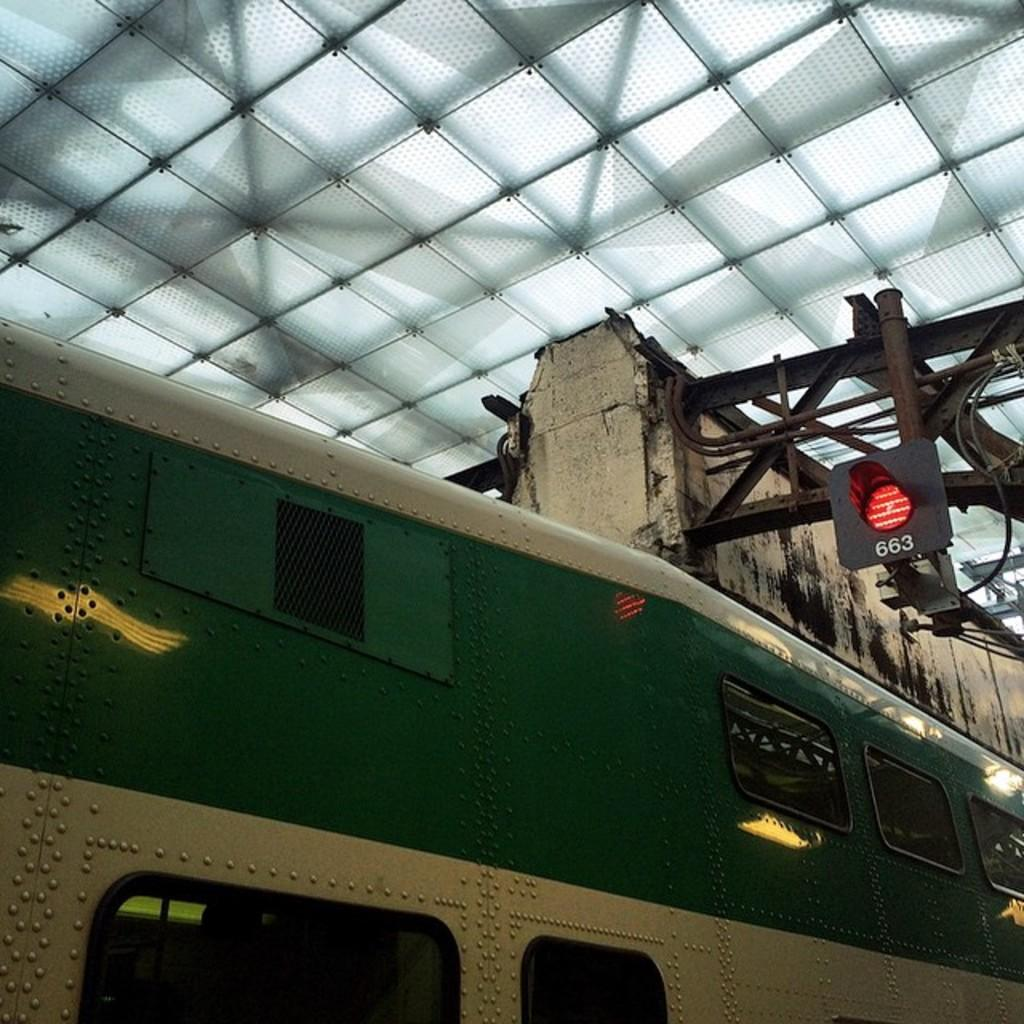What is the main subject of the image? There is a train in the image. What colors are used for the train? The train is in cream and green color. What can be seen in the background of the image? There is a ceiling visible in the background of the image. What type of lighting is present in the background? There is a light attached to a metal rod in the background of the image. What type of quilt is being used to cover the train in the image? There is no quilt present in the image; it features a train with a cream and green color scheme. How does the building in the image affect the movement of the train? There is no building present in the image, only a train, a ceiling, and a light attached to a metal rod. 